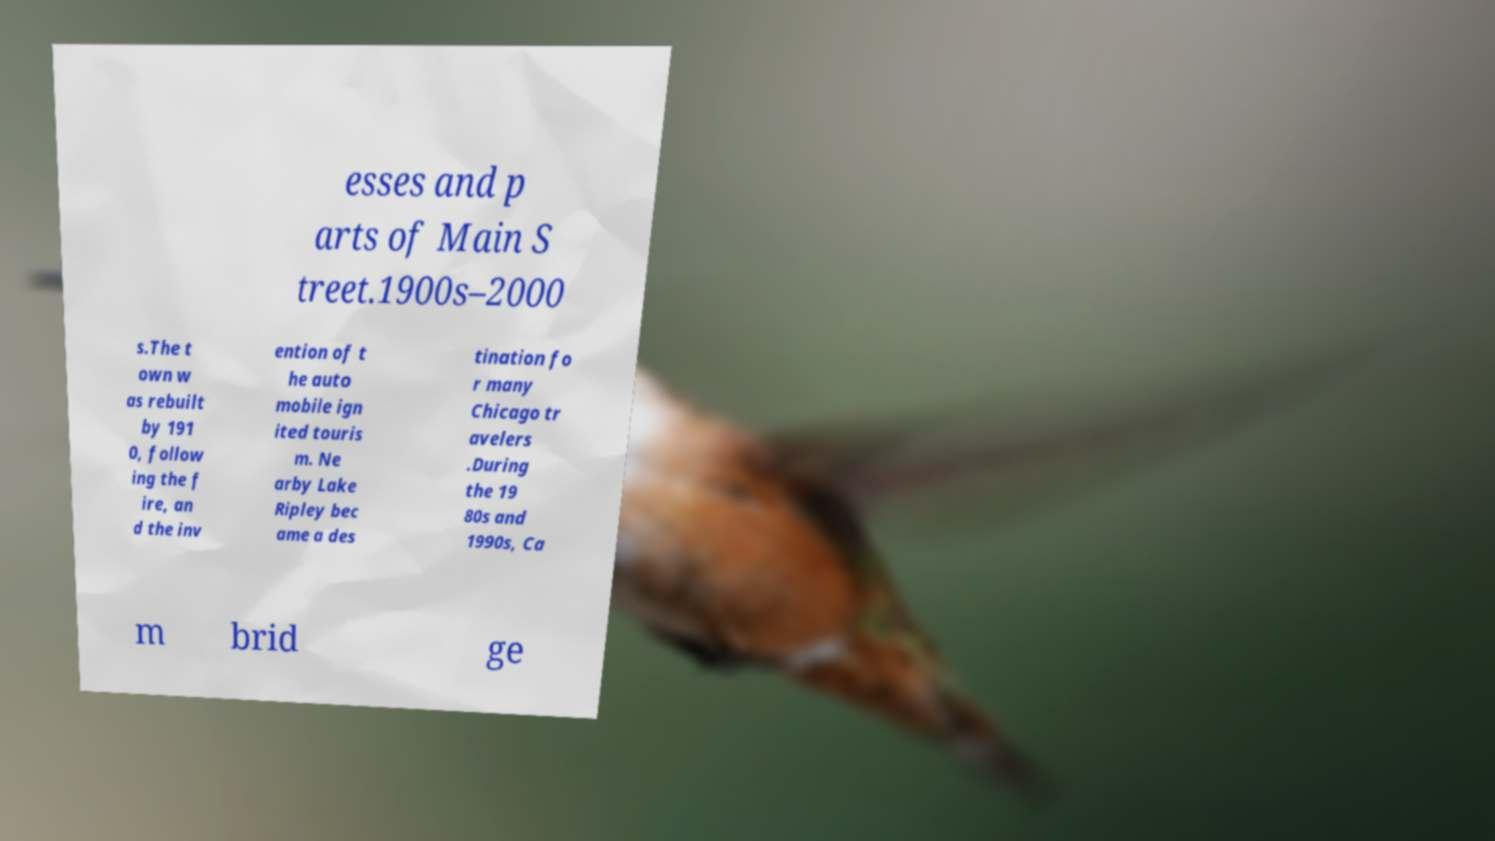For documentation purposes, I need the text within this image transcribed. Could you provide that? esses and p arts of Main S treet.1900s–2000 s.The t own w as rebuilt by 191 0, follow ing the f ire, an d the inv ention of t he auto mobile ign ited touris m. Ne arby Lake Ripley bec ame a des tination fo r many Chicago tr avelers .During the 19 80s and 1990s, Ca m brid ge 